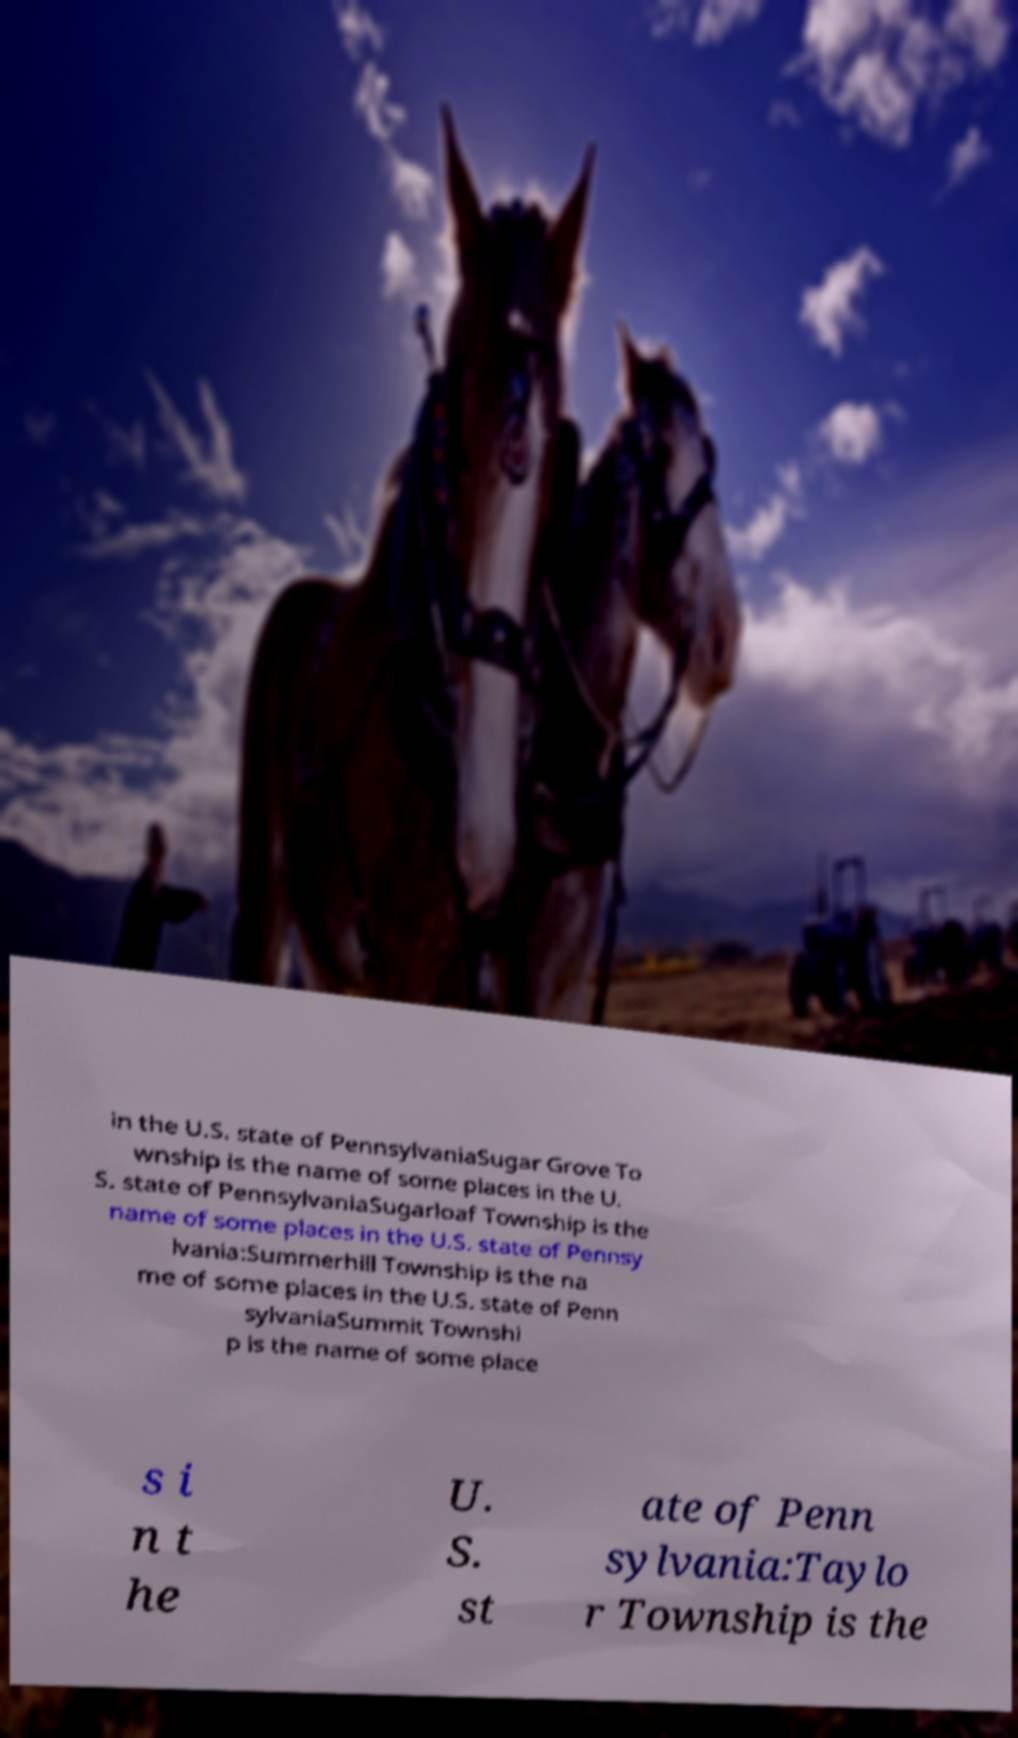Could you extract and type out the text from this image? in the U.S. state of PennsylvaniaSugar Grove To wnship is the name of some places in the U. S. state of PennsylvaniaSugarloaf Township is the name of some places in the U.S. state of Pennsy lvania:Summerhill Township is the na me of some places in the U.S. state of Penn sylvaniaSummit Townshi p is the name of some place s i n t he U. S. st ate of Penn sylvania:Taylo r Township is the 